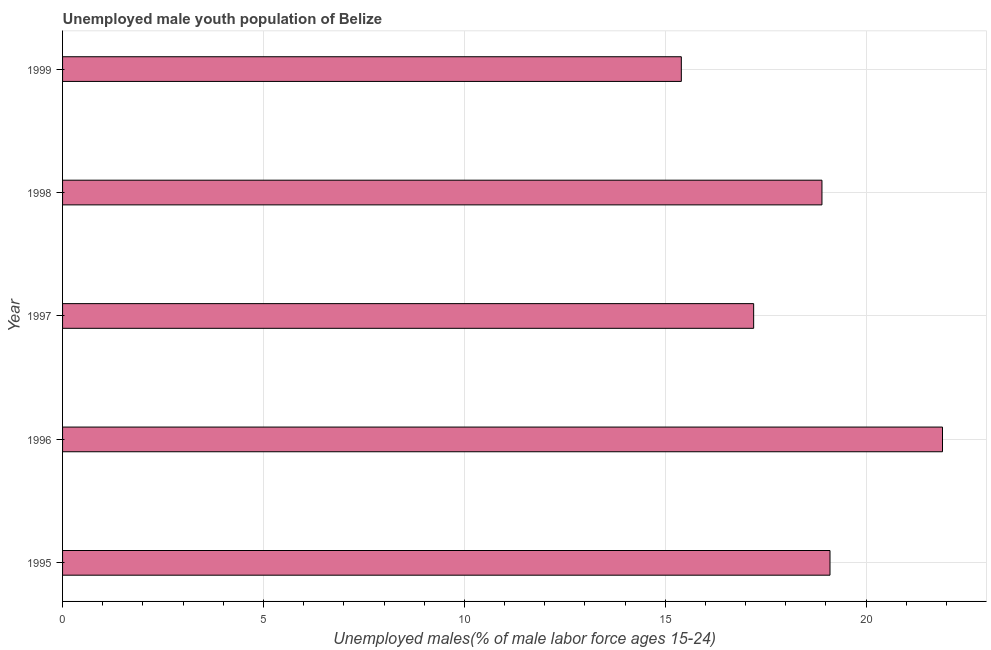Does the graph contain any zero values?
Give a very brief answer. No. Does the graph contain grids?
Provide a succinct answer. Yes. What is the title of the graph?
Keep it short and to the point. Unemployed male youth population of Belize. What is the label or title of the X-axis?
Make the answer very short. Unemployed males(% of male labor force ages 15-24). What is the label or title of the Y-axis?
Ensure brevity in your answer.  Year. What is the unemployed male youth in 1997?
Your response must be concise. 17.2. Across all years, what is the maximum unemployed male youth?
Provide a succinct answer. 21.9. Across all years, what is the minimum unemployed male youth?
Make the answer very short. 15.4. In which year was the unemployed male youth minimum?
Offer a terse response. 1999. What is the sum of the unemployed male youth?
Keep it short and to the point. 92.5. What is the median unemployed male youth?
Make the answer very short. 18.9. What is the ratio of the unemployed male youth in 1996 to that in 1999?
Your answer should be compact. 1.42. Is the unemployed male youth in 1995 less than that in 1996?
Your answer should be very brief. Yes. Is the difference between the unemployed male youth in 1996 and 1997 greater than the difference between any two years?
Offer a very short reply. No. What is the difference between the highest and the second highest unemployed male youth?
Provide a succinct answer. 2.8. Is the sum of the unemployed male youth in 1995 and 1999 greater than the maximum unemployed male youth across all years?
Your answer should be compact. Yes. In how many years, is the unemployed male youth greater than the average unemployed male youth taken over all years?
Provide a short and direct response. 3. How many bars are there?
Make the answer very short. 5. Are all the bars in the graph horizontal?
Offer a terse response. Yes. What is the Unemployed males(% of male labor force ages 15-24) in 1995?
Make the answer very short. 19.1. What is the Unemployed males(% of male labor force ages 15-24) in 1996?
Ensure brevity in your answer.  21.9. What is the Unemployed males(% of male labor force ages 15-24) in 1997?
Your answer should be compact. 17.2. What is the Unemployed males(% of male labor force ages 15-24) of 1998?
Give a very brief answer. 18.9. What is the Unemployed males(% of male labor force ages 15-24) in 1999?
Make the answer very short. 15.4. What is the difference between the Unemployed males(% of male labor force ages 15-24) in 1995 and 1998?
Make the answer very short. 0.2. What is the difference between the Unemployed males(% of male labor force ages 15-24) in 1996 and 1998?
Ensure brevity in your answer.  3. What is the difference between the Unemployed males(% of male labor force ages 15-24) in 1996 and 1999?
Ensure brevity in your answer.  6.5. What is the difference between the Unemployed males(% of male labor force ages 15-24) in 1997 and 1998?
Your response must be concise. -1.7. What is the difference between the Unemployed males(% of male labor force ages 15-24) in 1998 and 1999?
Your answer should be very brief. 3.5. What is the ratio of the Unemployed males(% of male labor force ages 15-24) in 1995 to that in 1996?
Provide a short and direct response. 0.87. What is the ratio of the Unemployed males(% of male labor force ages 15-24) in 1995 to that in 1997?
Your answer should be compact. 1.11. What is the ratio of the Unemployed males(% of male labor force ages 15-24) in 1995 to that in 1999?
Provide a succinct answer. 1.24. What is the ratio of the Unemployed males(% of male labor force ages 15-24) in 1996 to that in 1997?
Provide a succinct answer. 1.27. What is the ratio of the Unemployed males(% of male labor force ages 15-24) in 1996 to that in 1998?
Your answer should be compact. 1.16. What is the ratio of the Unemployed males(% of male labor force ages 15-24) in 1996 to that in 1999?
Make the answer very short. 1.42. What is the ratio of the Unemployed males(% of male labor force ages 15-24) in 1997 to that in 1998?
Keep it short and to the point. 0.91. What is the ratio of the Unemployed males(% of male labor force ages 15-24) in 1997 to that in 1999?
Your answer should be compact. 1.12. What is the ratio of the Unemployed males(% of male labor force ages 15-24) in 1998 to that in 1999?
Give a very brief answer. 1.23. 